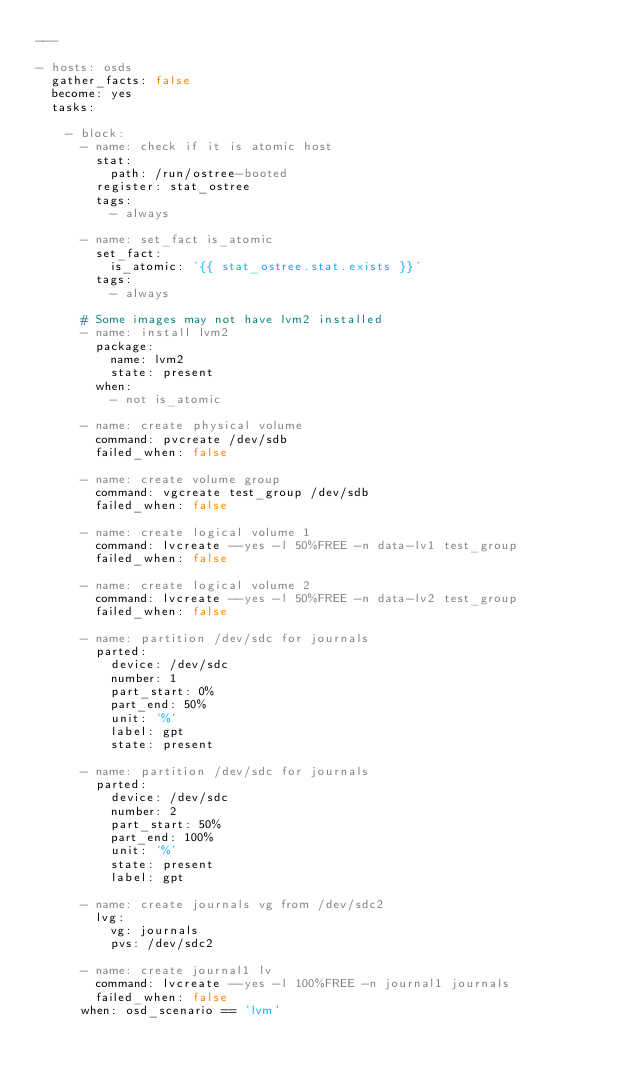<code> <loc_0><loc_0><loc_500><loc_500><_YAML_>---

- hosts: osds
  gather_facts: false
  become: yes
  tasks:

    - block:
      - name: check if it is atomic host
        stat:
          path: /run/ostree-booted
        register: stat_ostree
        tags:
          - always

      - name: set_fact is_atomic
        set_fact:
          is_atomic: '{{ stat_ostree.stat.exists }}'
        tags:
          - always

      # Some images may not have lvm2 installed
      - name: install lvm2
        package:
          name: lvm2
          state: present
        when:
          - not is_atomic

      - name: create physical volume
        command: pvcreate /dev/sdb
        failed_when: false

      - name: create volume group
        command: vgcreate test_group /dev/sdb
        failed_when: false

      - name: create logical volume 1
        command: lvcreate --yes -l 50%FREE -n data-lv1 test_group
        failed_when: false

      - name: create logical volume 2
        command: lvcreate --yes -l 50%FREE -n data-lv2 test_group
        failed_when: false

      - name: partition /dev/sdc for journals
        parted:
          device: /dev/sdc
          number: 1
          part_start: 0%
          part_end: 50%
          unit: '%'
          label: gpt
          state: present

      - name: partition /dev/sdc for journals
        parted:
          device: /dev/sdc
          number: 2
          part_start: 50%
          part_end: 100%
          unit: '%'
          state: present
          label: gpt

      - name: create journals vg from /dev/sdc2
        lvg:
          vg: journals
          pvs: /dev/sdc2

      - name: create journal1 lv
        command: lvcreate --yes -l 100%FREE -n journal1 journals
        failed_when: false
      when: osd_scenario == 'lvm'
</code> 